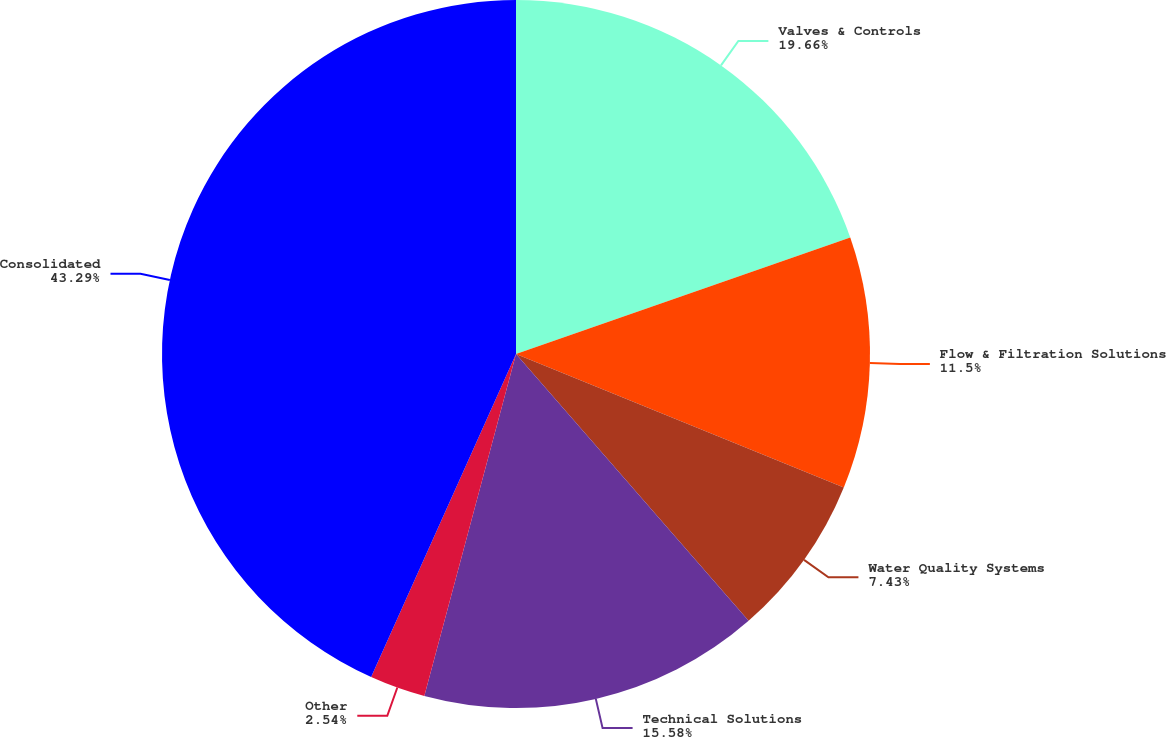Convert chart to OTSL. <chart><loc_0><loc_0><loc_500><loc_500><pie_chart><fcel>Valves & Controls<fcel>Flow & Filtration Solutions<fcel>Water Quality Systems<fcel>Technical Solutions<fcel>Other<fcel>Consolidated<nl><fcel>19.66%<fcel>11.5%<fcel>7.43%<fcel>15.58%<fcel>2.54%<fcel>43.29%<nl></chart> 